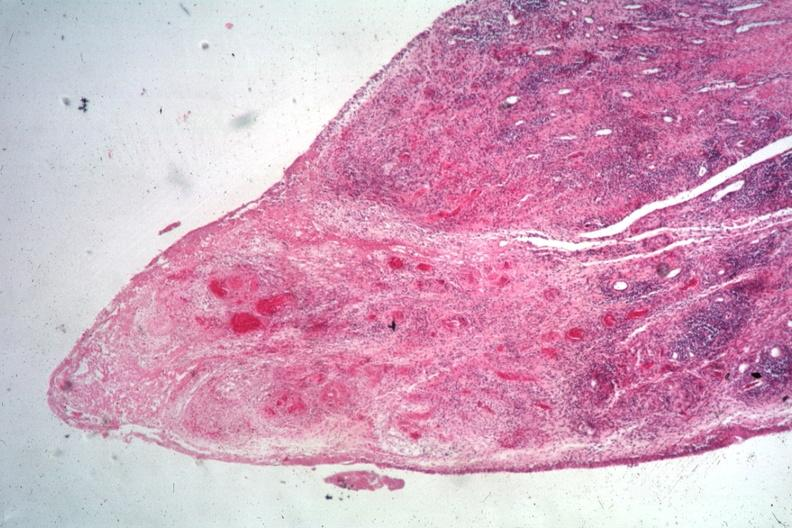does gangrene toe in infant show typical lesion case associated with widespread vasculitis?
Answer the question using a single word or phrase. No 